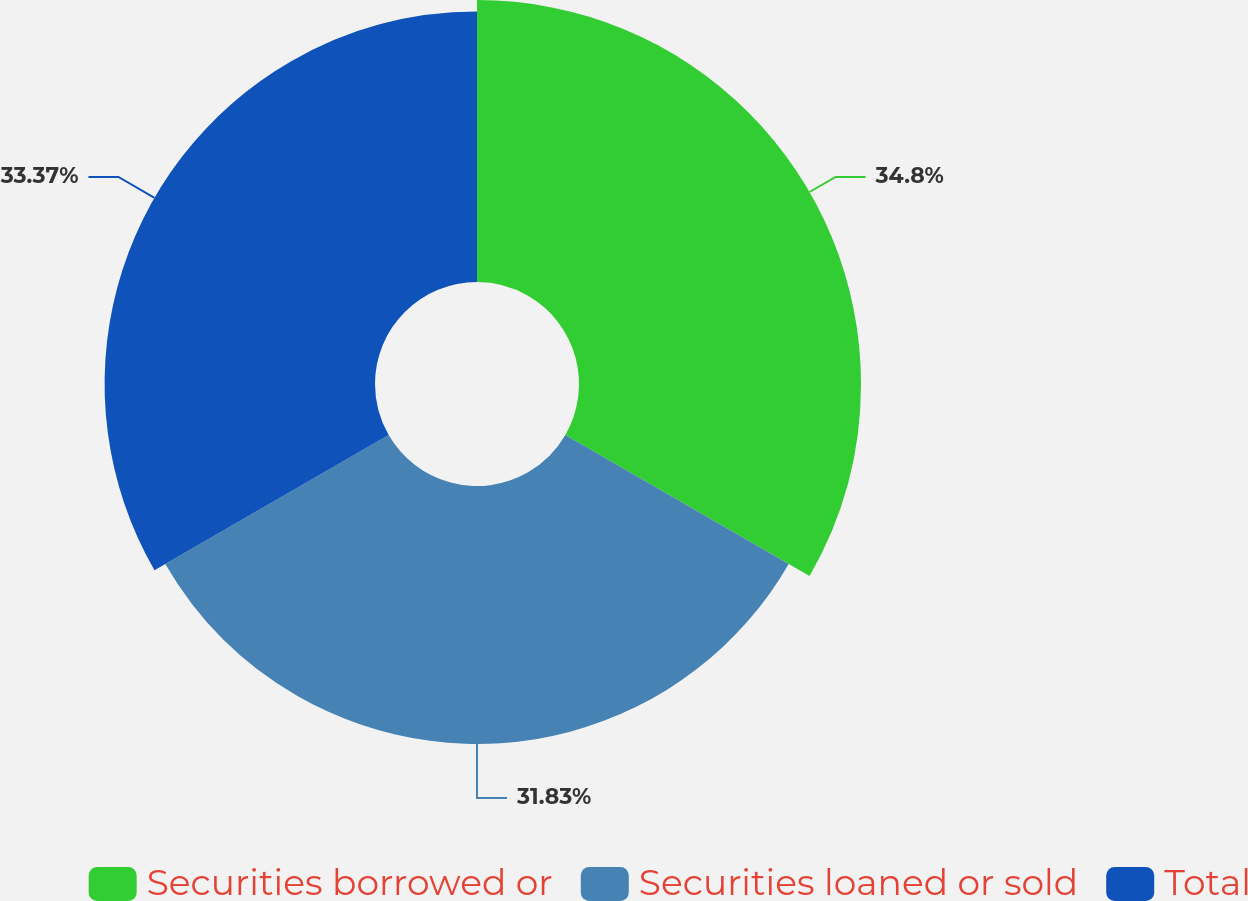Convert chart to OTSL. <chart><loc_0><loc_0><loc_500><loc_500><pie_chart><fcel>Securities borrowed or<fcel>Securities loaned or sold<fcel>Total<nl><fcel>34.8%<fcel>31.83%<fcel>33.37%<nl></chart> 